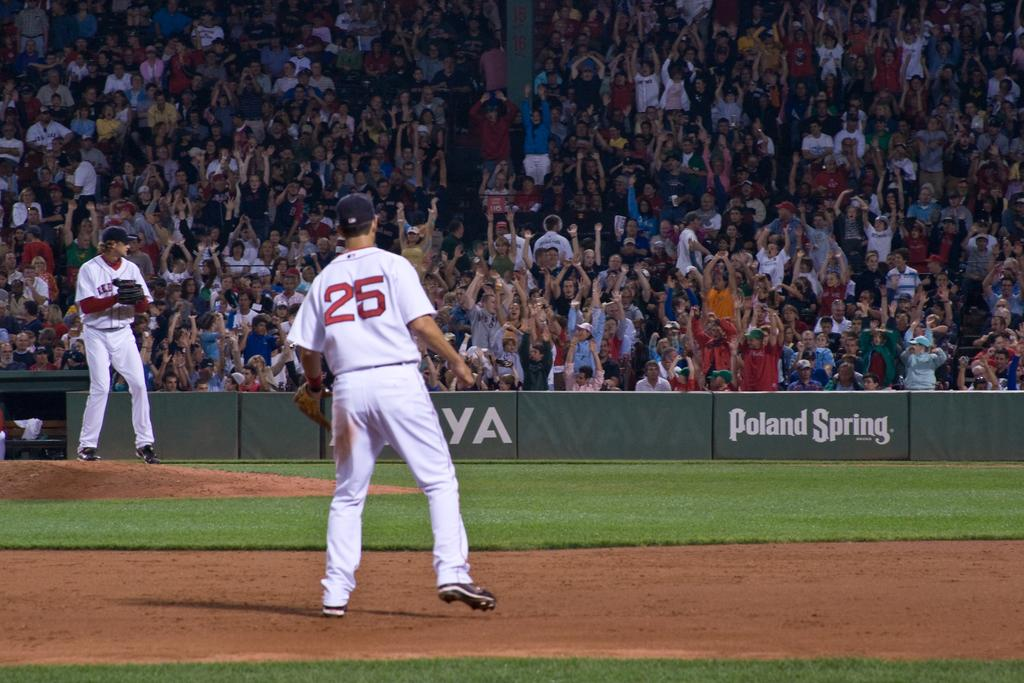<image>
Give a short and clear explanation of the subsequent image. a player that has the number 25 on their jersey 